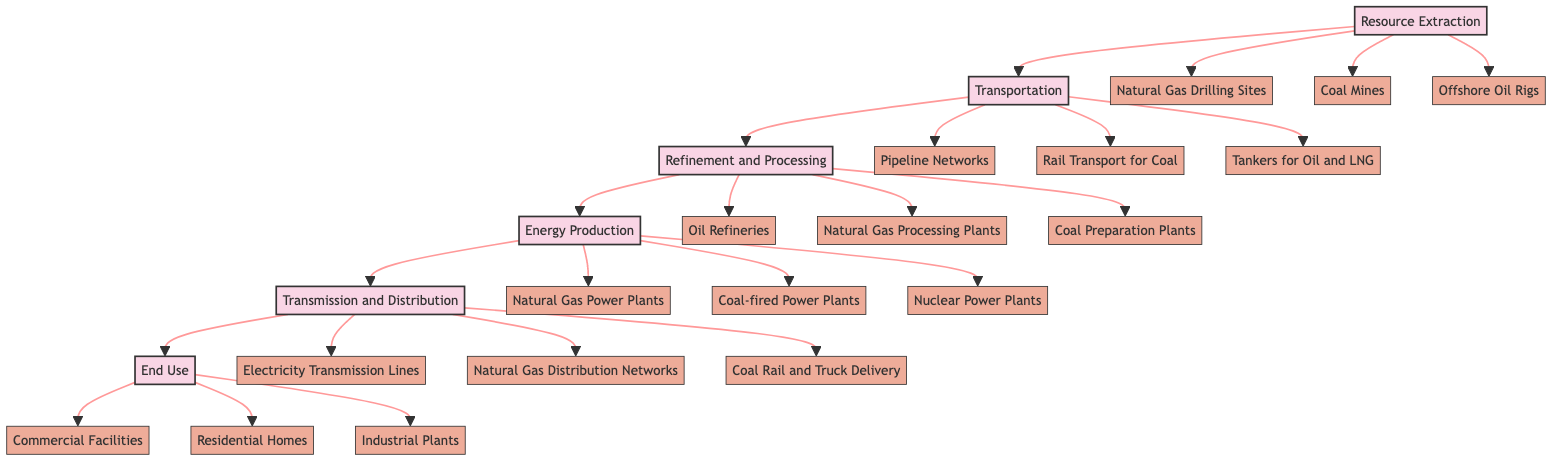What are the entities associated with Resource Extraction? The diagram shows that the Resource Extraction stage includes three entities: Natural Gas Drilling Sites, Coal Mines, and Offshore Oil Rigs.
Answer: Natural Gas Drilling Sites, Coal Mines, Offshore Oil Rigs How many stages are there in the energy supply chain? By counting the distinct stages in the diagram, we have Resource Extraction, Transportation, Refinement and Processing, Energy Production, Transmission and Distribution, and End Use, totaling six stages.
Answer: 6 Which stage comes after Refinement and Processing? According to the flow of the diagram, after the Refinement and Processing stage, the next stage is Energy Production.
Answer: Energy Production How many entities are there in the Transmission and Distribution stage? The diagram lists three entities under the Transmission and Distribution stage: Electricity Transmission Lines, Natural Gas Distribution Networks, and Coal Rail and Truck Delivery, so there are a total of three entities.
Answer: 3 What is the first stage in the energy supply chain? The diagram indicates that the first stage in the energy supply chain is Resource Extraction.
Answer: Resource Extraction Which entities correspond to the Energy Production stage? The Energy Production stage includes three entities: Natural Gas Power Plants, Coal-fired Power Plants, and Nuclear Power Plants, which detail the types of facilities involved in energy generation.
Answer: Natural Gas Power Plants, Coal-fired Power Plants, Nuclear Power Plants What type of transport is used for coal? The diagram specifies that Rail Transport for Coal is the designated transport method within the Transportation stage for coal.
Answer: Rail Transport for Coal What is the last stage in the energy supply chain? In the flow of the diagram, the last stage is End Use, which represents where the energy is ultimately consumed.
Answer: End Use How do the stages of the energy supply chain connect to one another? The flowchart shows a sequential connection, starting from Resource Extraction, moving through each subsequent stage—Transportation, Refinement and Processing, Energy Production, Transmission and Distribution, and finally ending at End Use, indicating a linear path of energy from source to consumer.
Answer: Sequential connection from Resource Extraction to End Use 